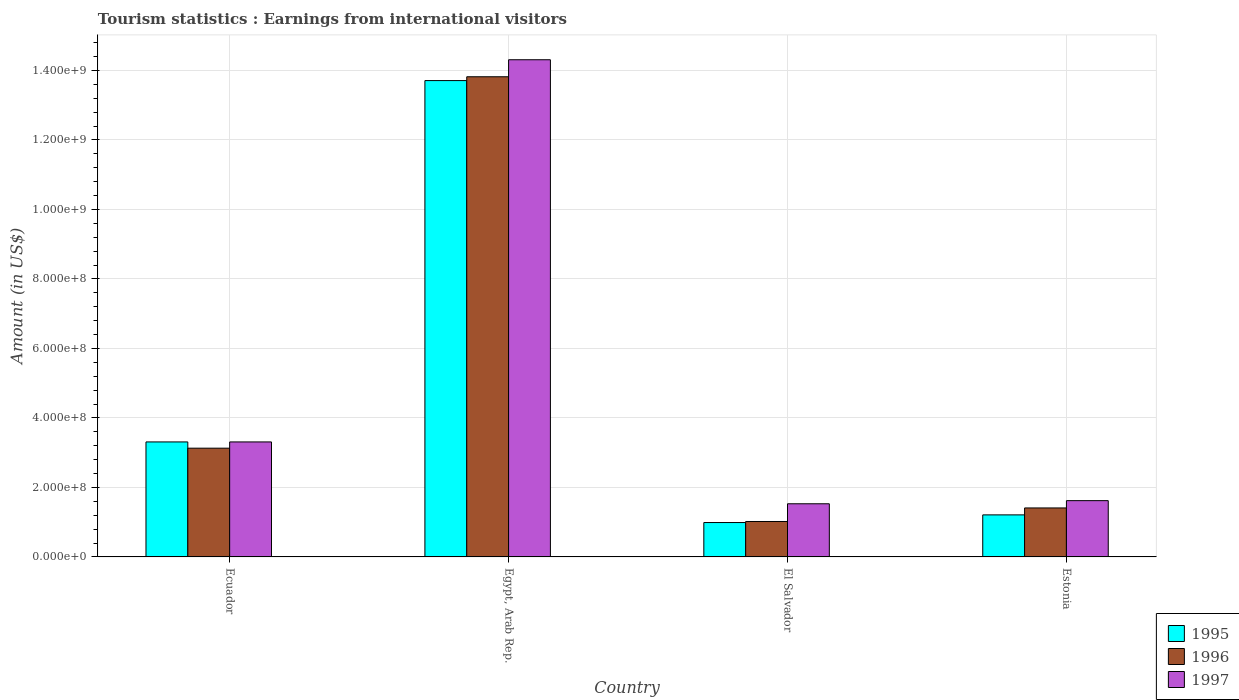How many different coloured bars are there?
Your response must be concise. 3. How many groups of bars are there?
Your answer should be compact. 4. Are the number of bars per tick equal to the number of legend labels?
Provide a short and direct response. Yes. How many bars are there on the 1st tick from the left?
Ensure brevity in your answer.  3. What is the label of the 1st group of bars from the left?
Keep it short and to the point. Ecuador. What is the earnings from international visitors in 1996 in Egypt, Arab Rep.?
Keep it short and to the point. 1.38e+09. Across all countries, what is the maximum earnings from international visitors in 1996?
Give a very brief answer. 1.38e+09. Across all countries, what is the minimum earnings from international visitors in 1997?
Your answer should be very brief. 1.53e+08. In which country was the earnings from international visitors in 1996 maximum?
Your answer should be compact. Egypt, Arab Rep. In which country was the earnings from international visitors in 1996 minimum?
Your answer should be very brief. El Salvador. What is the total earnings from international visitors in 1995 in the graph?
Give a very brief answer. 1.92e+09. What is the difference between the earnings from international visitors in 1996 in Egypt, Arab Rep. and that in El Salvador?
Your answer should be very brief. 1.28e+09. What is the difference between the earnings from international visitors in 1995 in El Salvador and the earnings from international visitors in 1997 in Egypt, Arab Rep.?
Provide a succinct answer. -1.33e+09. What is the average earnings from international visitors in 1997 per country?
Ensure brevity in your answer.  5.19e+08. What is the difference between the earnings from international visitors of/in 1995 and earnings from international visitors of/in 1996 in Egypt, Arab Rep.?
Offer a terse response. -1.10e+07. In how many countries, is the earnings from international visitors in 1995 greater than 320000000 US$?
Your response must be concise. 2. What is the ratio of the earnings from international visitors in 1995 in Egypt, Arab Rep. to that in Estonia?
Provide a succinct answer. 11.33. Is the difference between the earnings from international visitors in 1995 in Ecuador and El Salvador greater than the difference between the earnings from international visitors in 1996 in Ecuador and El Salvador?
Give a very brief answer. Yes. What is the difference between the highest and the second highest earnings from international visitors in 1997?
Keep it short and to the point. 1.27e+09. What is the difference between the highest and the lowest earnings from international visitors in 1997?
Give a very brief answer. 1.28e+09. In how many countries, is the earnings from international visitors in 1996 greater than the average earnings from international visitors in 1996 taken over all countries?
Keep it short and to the point. 1. Is the sum of the earnings from international visitors in 1997 in Ecuador and Egypt, Arab Rep. greater than the maximum earnings from international visitors in 1995 across all countries?
Your response must be concise. Yes. What does the 2nd bar from the right in Egypt, Arab Rep. represents?
Make the answer very short. 1996. Is it the case that in every country, the sum of the earnings from international visitors in 1997 and earnings from international visitors in 1995 is greater than the earnings from international visitors in 1996?
Offer a very short reply. Yes. What is the difference between two consecutive major ticks on the Y-axis?
Your answer should be very brief. 2.00e+08. Does the graph contain grids?
Offer a terse response. Yes. Where does the legend appear in the graph?
Make the answer very short. Bottom right. How many legend labels are there?
Your response must be concise. 3. What is the title of the graph?
Keep it short and to the point. Tourism statistics : Earnings from international visitors. What is the label or title of the Y-axis?
Make the answer very short. Amount (in US$). What is the Amount (in US$) in 1995 in Ecuador?
Provide a succinct answer. 3.31e+08. What is the Amount (in US$) in 1996 in Ecuador?
Give a very brief answer. 3.13e+08. What is the Amount (in US$) of 1997 in Ecuador?
Give a very brief answer. 3.31e+08. What is the Amount (in US$) in 1995 in Egypt, Arab Rep.?
Make the answer very short. 1.37e+09. What is the Amount (in US$) of 1996 in Egypt, Arab Rep.?
Give a very brief answer. 1.38e+09. What is the Amount (in US$) in 1997 in Egypt, Arab Rep.?
Make the answer very short. 1.43e+09. What is the Amount (in US$) of 1995 in El Salvador?
Give a very brief answer. 9.90e+07. What is the Amount (in US$) of 1996 in El Salvador?
Your response must be concise. 1.02e+08. What is the Amount (in US$) of 1997 in El Salvador?
Your answer should be very brief. 1.53e+08. What is the Amount (in US$) of 1995 in Estonia?
Provide a short and direct response. 1.21e+08. What is the Amount (in US$) of 1996 in Estonia?
Ensure brevity in your answer.  1.41e+08. What is the Amount (in US$) of 1997 in Estonia?
Your answer should be very brief. 1.62e+08. Across all countries, what is the maximum Amount (in US$) in 1995?
Your response must be concise. 1.37e+09. Across all countries, what is the maximum Amount (in US$) of 1996?
Your answer should be compact. 1.38e+09. Across all countries, what is the maximum Amount (in US$) in 1997?
Offer a very short reply. 1.43e+09. Across all countries, what is the minimum Amount (in US$) of 1995?
Your answer should be compact. 9.90e+07. Across all countries, what is the minimum Amount (in US$) of 1996?
Provide a short and direct response. 1.02e+08. Across all countries, what is the minimum Amount (in US$) in 1997?
Your response must be concise. 1.53e+08. What is the total Amount (in US$) of 1995 in the graph?
Offer a very short reply. 1.92e+09. What is the total Amount (in US$) in 1996 in the graph?
Ensure brevity in your answer.  1.94e+09. What is the total Amount (in US$) of 1997 in the graph?
Your response must be concise. 2.08e+09. What is the difference between the Amount (in US$) of 1995 in Ecuador and that in Egypt, Arab Rep.?
Offer a terse response. -1.04e+09. What is the difference between the Amount (in US$) in 1996 in Ecuador and that in Egypt, Arab Rep.?
Ensure brevity in your answer.  -1.07e+09. What is the difference between the Amount (in US$) of 1997 in Ecuador and that in Egypt, Arab Rep.?
Give a very brief answer. -1.10e+09. What is the difference between the Amount (in US$) in 1995 in Ecuador and that in El Salvador?
Offer a terse response. 2.32e+08. What is the difference between the Amount (in US$) of 1996 in Ecuador and that in El Salvador?
Provide a short and direct response. 2.11e+08. What is the difference between the Amount (in US$) of 1997 in Ecuador and that in El Salvador?
Your answer should be very brief. 1.78e+08. What is the difference between the Amount (in US$) of 1995 in Ecuador and that in Estonia?
Keep it short and to the point. 2.10e+08. What is the difference between the Amount (in US$) of 1996 in Ecuador and that in Estonia?
Offer a very short reply. 1.72e+08. What is the difference between the Amount (in US$) in 1997 in Ecuador and that in Estonia?
Ensure brevity in your answer.  1.69e+08. What is the difference between the Amount (in US$) of 1995 in Egypt, Arab Rep. and that in El Salvador?
Offer a very short reply. 1.27e+09. What is the difference between the Amount (in US$) of 1996 in Egypt, Arab Rep. and that in El Salvador?
Offer a terse response. 1.28e+09. What is the difference between the Amount (in US$) in 1997 in Egypt, Arab Rep. and that in El Salvador?
Your answer should be compact. 1.28e+09. What is the difference between the Amount (in US$) of 1995 in Egypt, Arab Rep. and that in Estonia?
Provide a succinct answer. 1.25e+09. What is the difference between the Amount (in US$) in 1996 in Egypt, Arab Rep. and that in Estonia?
Keep it short and to the point. 1.24e+09. What is the difference between the Amount (in US$) in 1997 in Egypt, Arab Rep. and that in Estonia?
Give a very brief answer. 1.27e+09. What is the difference between the Amount (in US$) of 1995 in El Salvador and that in Estonia?
Provide a succinct answer. -2.20e+07. What is the difference between the Amount (in US$) in 1996 in El Salvador and that in Estonia?
Make the answer very short. -3.90e+07. What is the difference between the Amount (in US$) of 1997 in El Salvador and that in Estonia?
Keep it short and to the point. -9.00e+06. What is the difference between the Amount (in US$) in 1995 in Ecuador and the Amount (in US$) in 1996 in Egypt, Arab Rep.?
Give a very brief answer. -1.05e+09. What is the difference between the Amount (in US$) in 1995 in Ecuador and the Amount (in US$) in 1997 in Egypt, Arab Rep.?
Ensure brevity in your answer.  -1.10e+09. What is the difference between the Amount (in US$) in 1996 in Ecuador and the Amount (in US$) in 1997 in Egypt, Arab Rep.?
Make the answer very short. -1.12e+09. What is the difference between the Amount (in US$) of 1995 in Ecuador and the Amount (in US$) of 1996 in El Salvador?
Your response must be concise. 2.29e+08. What is the difference between the Amount (in US$) of 1995 in Ecuador and the Amount (in US$) of 1997 in El Salvador?
Provide a succinct answer. 1.78e+08. What is the difference between the Amount (in US$) in 1996 in Ecuador and the Amount (in US$) in 1997 in El Salvador?
Give a very brief answer. 1.60e+08. What is the difference between the Amount (in US$) in 1995 in Ecuador and the Amount (in US$) in 1996 in Estonia?
Your response must be concise. 1.90e+08. What is the difference between the Amount (in US$) of 1995 in Ecuador and the Amount (in US$) of 1997 in Estonia?
Offer a terse response. 1.69e+08. What is the difference between the Amount (in US$) of 1996 in Ecuador and the Amount (in US$) of 1997 in Estonia?
Your response must be concise. 1.51e+08. What is the difference between the Amount (in US$) in 1995 in Egypt, Arab Rep. and the Amount (in US$) in 1996 in El Salvador?
Give a very brief answer. 1.27e+09. What is the difference between the Amount (in US$) of 1995 in Egypt, Arab Rep. and the Amount (in US$) of 1997 in El Salvador?
Your answer should be compact. 1.22e+09. What is the difference between the Amount (in US$) of 1996 in Egypt, Arab Rep. and the Amount (in US$) of 1997 in El Salvador?
Offer a terse response. 1.23e+09. What is the difference between the Amount (in US$) in 1995 in Egypt, Arab Rep. and the Amount (in US$) in 1996 in Estonia?
Your answer should be compact. 1.23e+09. What is the difference between the Amount (in US$) in 1995 in Egypt, Arab Rep. and the Amount (in US$) in 1997 in Estonia?
Your answer should be compact. 1.21e+09. What is the difference between the Amount (in US$) of 1996 in Egypt, Arab Rep. and the Amount (in US$) of 1997 in Estonia?
Ensure brevity in your answer.  1.22e+09. What is the difference between the Amount (in US$) of 1995 in El Salvador and the Amount (in US$) of 1996 in Estonia?
Make the answer very short. -4.20e+07. What is the difference between the Amount (in US$) in 1995 in El Salvador and the Amount (in US$) in 1997 in Estonia?
Make the answer very short. -6.30e+07. What is the difference between the Amount (in US$) in 1996 in El Salvador and the Amount (in US$) in 1997 in Estonia?
Keep it short and to the point. -6.00e+07. What is the average Amount (in US$) in 1995 per country?
Keep it short and to the point. 4.80e+08. What is the average Amount (in US$) of 1996 per country?
Provide a short and direct response. 4.84e+08. What is the average Amount (in US$) of 1997 per country?
Your answer should be compact. 5.19e+08. What is the difference between the Amount (in US$) in 1995 and Amount (in US$) in 1996 in Ecuador?
Offer a very short reply. 1.80e+07. What is the difference between the Amount (in US$) in 1996 and Amount (in US$) in 1997 in Ecuador?
Offer a very short reply. -1.80e+07. What is the difference between the Amount (in US$) in 1995 and Amount (in US$) in 1996 in Egypt, Arab Rep.?
Offer a terse response. -1.10e+07. What is the difference between the Amount (in US$) in 1995 and Amount (in US$) in 1997 in Egypt, Arab Rep.?
Your answer should be compact. -6.00e+07. What is the difference between the Amount (in US$) of 1996 and Amount (in US$) of 1997 in Egypt, Arab Rep.?
Provide a short and direct response. -4.90e+07. What is the difference between the Amount (in US$) of 1995 and Amount (in US$) of 1997 in El Salvador?
Provide a succinct answer. -5.40e+07. What is the difference between the Amount (in US$) of 1996 and Amount (in US$) of 1997 in El Salvador?
Offer a terse response. -5.10e+07. What is the difference between the Amount (in US$) of 1995 and Amount (in US$) of 1996 in Estonia?
Give a very brief answer. -2.00e+07. What is the difference between the Amount (in US$) in 1995 and Amount (in US$) in 1997 in Estonia?
Ensure brevity in your answer.  -4.10e+07. What is the difference between the Amount (in US$) in 1996 and Amount (in US$) in 1997 in Estonia?
Your answer should be compact. -2.10e+07. What is the ratio of the Amount (in US$) of 1995 in Ecuador to that in Egypt, Arab Rep.?
Your answer should be very brief. 0.24. What is the ratio of the Amount (in US$) of 1996 in Ecuador to that in Egypt, Arab Rep.?
Offer a terse response. 0.23. What is the ratio of the Amount (in US$) of 1997 in Ecuador to that in Egypt, Arab Rep.?
Offer a terse response. 0.23. What is the ratio of the Amount (in US$) of 1995 in Ecuador to that in El Salvador?
Your answer should be very brief. 3.34. What is the ratio of the Amount (in US$) in 1996 in Ecuador to that in El Salvador?
Your response must be concise. 3.07. What is the ratio of the Amount (in US$) of 1997 in Ecuador to that in El Salvador?
Provide a short and direct response. 2.16. What is the ratio of the Amount (in US$) of 1995 in Ecuador to that in Estonia?
Your answer should be compact. 2.74. What is the ratio of the Amount (in US$) in 1996 in Ecuador to that in Estonia?
Your answer should be compact. 2.22. What is the ratio of the Amount (in US$) of 1997 in Ecuador to that in Estonia?
Give a very brief answer. 2.04. What is the ratio of the Amount (in US$) in 1995 in Egypt, Arab Rep. to that in El Salvador?
Offer a terse response. 13.85. What is the ratio of the Amount (in US$) of 1996 in Egypt, Arab Rep. to that in El Salvador?
Provide a succinct answer. 13.55. What is the ratio of the Amount (in US$) in 1997 in Egypt, Arab Rep. to that in El Salvador?
Give a very brief answer. 9.35. What is the ratio of the Amount (in US$) of 1995 in Egypt, Arab Rep. to that in Estonia?
Provide a short and direct response. 11.33. What is the ratio of the Amount (in US$) of 1996 in Egypt, Arab Rep. to that in Estonia?
Provide a short and direct response. 9.8. What is the ratio of the Amount (in US$) in 1997 in Egypt, Arab Rep. to that in Estonia?
Provide a succinct answer. 8.83. What is the ratio of the Amount (in US$) in 1995 in El Salvador to that in Estonia?
Your answer should be very brief. 0.82. What is the ratio of the Amount (in US$) in 1996 in El Salvador to that in Estonia?
Give a very brief answer. 0.72. What is the ratio of the Amount (in US$) in 1997 in El Salvador to that in Estonia?
Offer a very short reply. 0.94. What is the difference between the highest and the second highest Amount (in US$) in 1995?
Provide a succinct answer. 1.04e+09. What is the difference between the highest and the second highest Amount (in US$) in 1996?
Your answer should be compact. 1.07e+09. What is the difference between the highest and the second highest Amount (in US$) of 1997?
Provide a succinct answer. 1.10e+09. What is the difference between the highest and the lowest Amount (in US$) in 1995?
Your response must be concise. 1.27e+09. What is the difference between the highest and the lowest Amount (in US$) of 1996?
Ensure brevity in your answer.  1.28e+09. What is the difference between the highest and the lowest Amount (in US$) of 1997?
Give a very brief answer. 1.28e+09. 